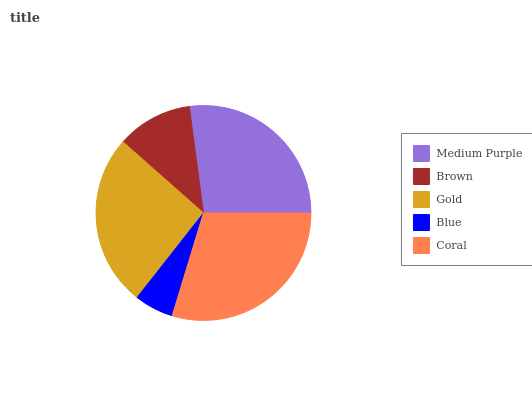Is Blue the minimum?
Answer yes or no. Yes. Is Coral the maximum?
Answer yes or no. Yes. Is Brown the minimum?
Answer yes or no. No. Is Brown the maximum?
Answer yes or no. No. Is Medium Purple greater than Brown?
Answer yes or no. Yes. Is Brown less than Medium Purple?
Answer yes or no. Yes. Is Brown greater than Medium Purple?
Answer yes or no. No. Is Medium Purple less than Brown?
Answer yes or no. No. Is Gold the high median?
Answer yes or no. Yes. Is Gold the low median?
Answer yes or no. Yes. Is Brown the high median?
Answer yes or no. No. Is Blue the low median?
Answer yes or no. No. 